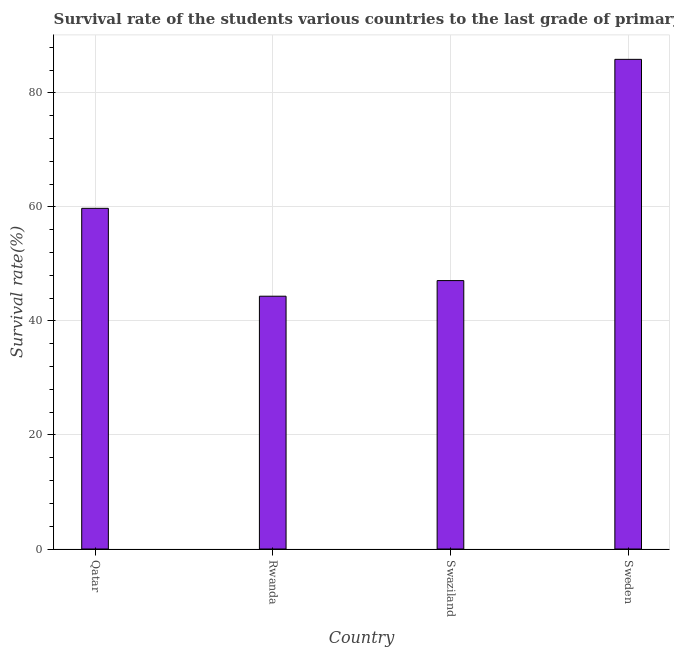Does the graph contain any zero values?
Your answer should be compact. No. Does the graph contain grids?
Provide a succinct answer. Yes. What is the title of the graph?
Ensure brevity in your answer.  Survival rate of the students various countries to the last grade of primary education. What is the label or title of the X-axis?
Make the answer very short. Country. What is the label or title of the Y-axis?
Your answer should be compact. Survival rate(%). What is the survival rate in primary education in Swaziland?
Provide a succinct answer. 47.09. Across all countries, what is the maximum survival rate in primary education?
Provide a succinct answer. 85.9. Across all countries, what is the minimum survival rate in primary education?
Provide a succinct answer. 44.35. In which country was the survival rate in primary education minimum?
Make the answer very short. Rwanda. What is the sum of the survival rate in primary education?
Offer a terse response. 237.1. What is the difference between the survival rate in primary education in Qatar and Rwanda?
Offer a very short reply. 15.42. What is the average survival rate in primary education per country?
Make the answer very short. 59.27. What is the median survival rate in primary education?
Offer a very short reply. 53.43. In how many countries, is the survival rate in primary education greater than 56 %?
Your answer should be very brief. 2. What is the ratio of the survival rate in primary education in Rwanda to that in Swaziland?
Provide a short and direct response. 0.94. Is the survival rate in primary education in Rwanda less than that in Sweden?
Ensure brevity in your answer.  Yes. Is the difference between the survival rate in primary education in Rwanda and Sweden greater than the difference between any two countries?
Make the answer very short. Yes. What is the difference between the highest and the second highest survival rate in primary education?
Offer a terse response. 26.14. What is the difference between the highest and the lowest survival rate in primary education?
Your answer should be compact. 41.55. In how many countries, is the survival rate in primary education greater than the average survival rate in primary education taken over all countries?
Make the answer very short. 2. How many bars are there?
Offer a very short reply. 4. How many countries are there in the graph?
Give a very brief answer. 4. What is the difference between two consecutive major ticks on the Y-axis?
Your response must be concise. 20. What is the Survival rate(%) in Qatar?
Keep it short and to the point. 59.76. What is the Survival rate(%) in Rwanda?
Make the answer very short. 44.35. What is the Survival rate(%) of Swaziland?
Your answer should be compact. 47.09. What is the Survival rate(%) in Sweden?
Offer a terse response. 85.9. What is the difference between the Survival rate(%) in Qatar and Rwanda?
Your answer should be compact. 15.42. What is the difference between the Survival rate(%) in Qatar and Swaziland?
Offer a very short reply. 12.67. What is the difference between the Survival rate(%) in Qatar and Sweden?
Ensure brevity in your answer.  -26.13. What is the difference between the Survival rate(%) in Rwanda and Swaziland?
Provide a short and direct response. -2.74. What is the difference between the Survival rate(%) in Rwanda and Sweden?
Your response must be concise. -41.55. What is the difference between the Survival rate(%) in Swaziland and Sweden?
Your answer should be compact. -38.81. What is the ratio of the Survival rate(%) in Qatar to that in Rwanda?
Offer a very short reply. 1.35. What is the ratio of the Survival rate(%) in Qatar to that in Swaziland?
Provide a succinct answer. 1.27. What is the ratio of the Survival rate(%) in Qatar to that in Sweden?
Your answer should be compact. 0.7. What is the ratio of the Survival rate(%) in Rwanda to that in Swaziland?
Make the answer very short. 0.94. What is the ratio of the Survival rate(%) in Rwanda to that in Sweden?
Offer a very short reply. 0.52. What is the ratio of the Survival rate(%) in Swaziland to that in Sweden?
Ensure brevity in your answer.  0.55. 